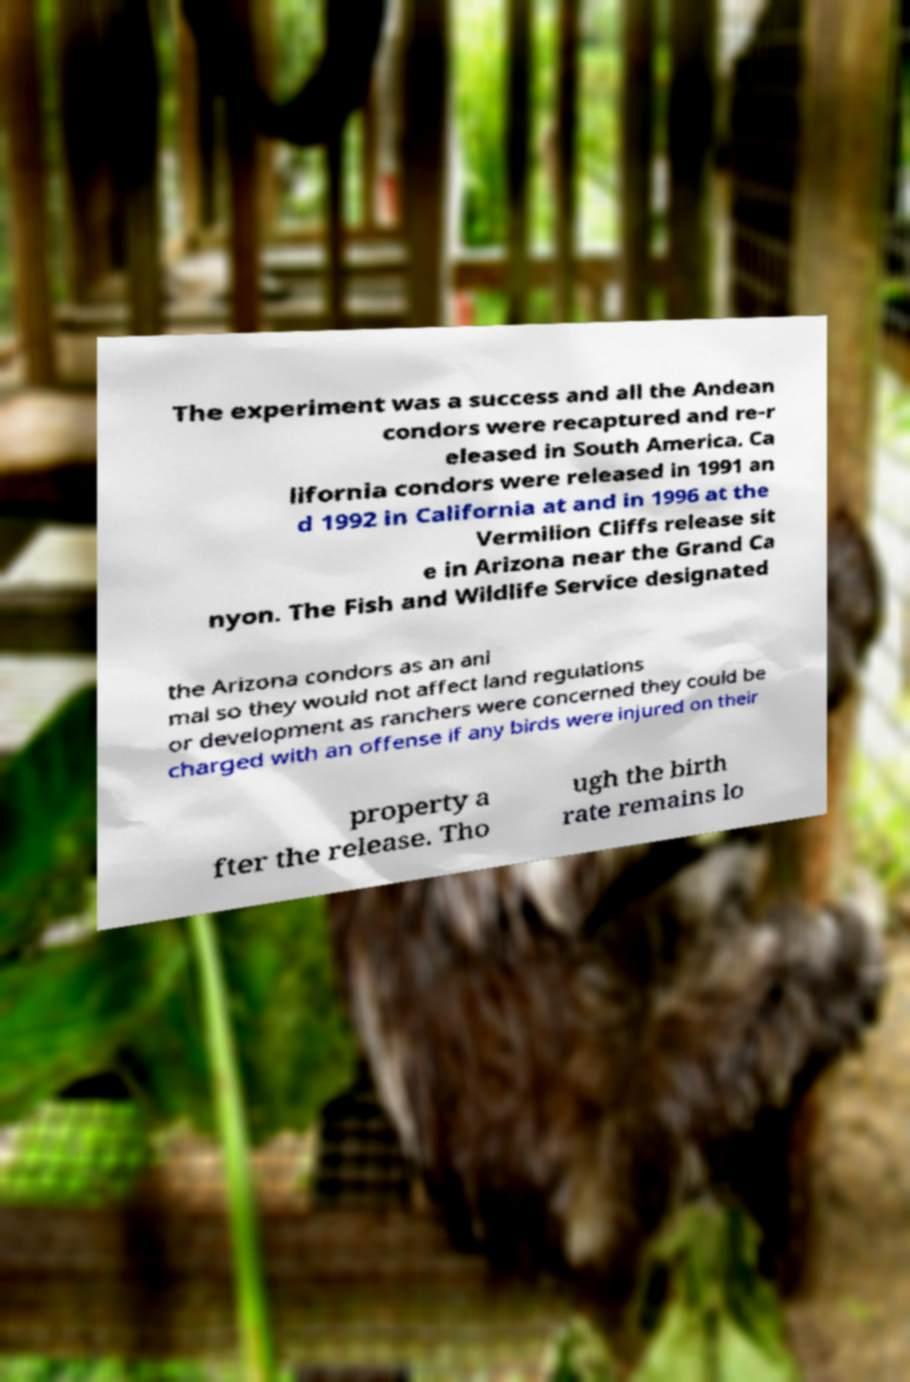There's text embedded in this image that I need extracted. Can you transcribe it verbatim? The experiment was a success and all the Andean condors were recaptured and re-r eleased in South America. Ca lifornia condors were released in 1991 an d 1992 in California at and in 1996 at the Vermilion Cliffs release sit e in Arizona near the Grand Ca nyon. The Fish and Wildlife Service designated the Arizona condors as an ani mal so they would not affect land regulations or development as ranchers were concerned they could be charged with an offense if any birds were injured on their property a fter the release. Tho ugh the birth rate remains lo 